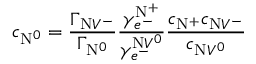<formula> <loc_0><loc_0><loc_500><loc_500>c _ { N ^ { 0 } } = \frac { \Gamma _ { N V ^ { - } } } { \Gamma _ { N ^ { 0 } } } \frac { \gamma _ { e ^ { - } } ^ { N ^ { + } } } { \gamma _ { e ^ { - } } ^ { N V ^ { 0 } } } \frac { c _ { N ^ { + } } c _ { N V ^ { - } } } { c _ { N V ^ { 0 } } }</formula> 